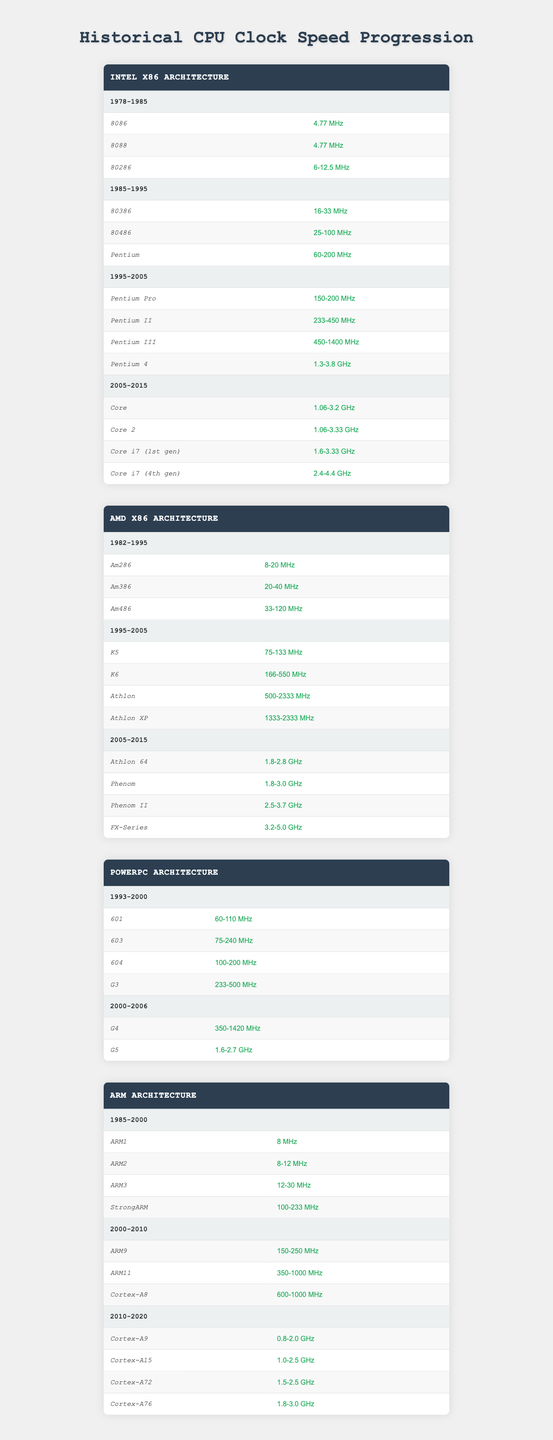What was the clock speed of the Pentium 4? According to the Intel x86 Architecture section of the table, the Pentium 4 has a clock speed ranging from 1.3 to 3.8 GHz.
Answer: 1.3-3.8 GHz Which CPU had the highest clock speed in the AMD x86 Architecture from 2005-2015? The table shows that the FX-Series had a clock speed ranging from 3.2 to 5.0 GHz, making it the highest in that period.
Answer: FX-Series How many clock speed options does the Core i7 (4th gen) have? The Core i7 (4th gen) has one clock speed option listed, which is 2.4-4.4 GHz.
Answer: 1 Did the clock speeds of CPUs generally increase from the 1980s to the 2010s? By reviewing the table, it is evident that clock speeds have generally increased over the decades as we progress from earlier models to those introduced later.
Answer: Yes What was the average clock speed of the Pentium II? The clock speed for the Pentium II is listed as 233-450 MHz; the average can be calculated as (233 + 450) / 2 = 341.5 MHz.
Answer: 341.5 MHz Which architecture featured the ARM Cortex-A15, and what period was it produced? The ARM Architecture features the Cortex-A15, which was produced during the period from 2010 to 2020.
Answer: ARM Architecture, 2010-2020 What is the range of clock speeds for the G4 in the PowerPC Architecture? The table specifies that the G4 has clock speeds ranging from 350 to 1420 MHz in the period from 2000 to 2006.
Answer: 350-1420 MHz Which CPU model had the lowest clock speed in the AMD x86 Architecture? The Am286 had the lowest clock speed in the AMD x86 Architecture, with a range of 8-20 MHz from 1982 to 1995.
Answer: Am286 How many CPUs listed in the Intel x86 Architecture had clock speeds above 2 GHz? From the data, the Core i7 (4th gen) and Pentium 4 are the two CPUs listed with speeds above 2 GHz, totaling to two CPUs.
Answer: 2 Which CPU had a clock speed that exceeded 2 GHz but below 3 GHz in the AMD x86 Architecture? The Phenom II has a clock speed range of 2.5-3.7 GHz, exceeding 2 GHz but below 3 GHz.
Answer: Phenom II What is the total range of clock speeds for the CPUs in the ARM Architecture from 1985 to 2000? The total clock speed ranges vary in that period, with the highest being StrongARM at 100-233 MHz, representing the total range for that time.
Answer: 8-233 MHz 